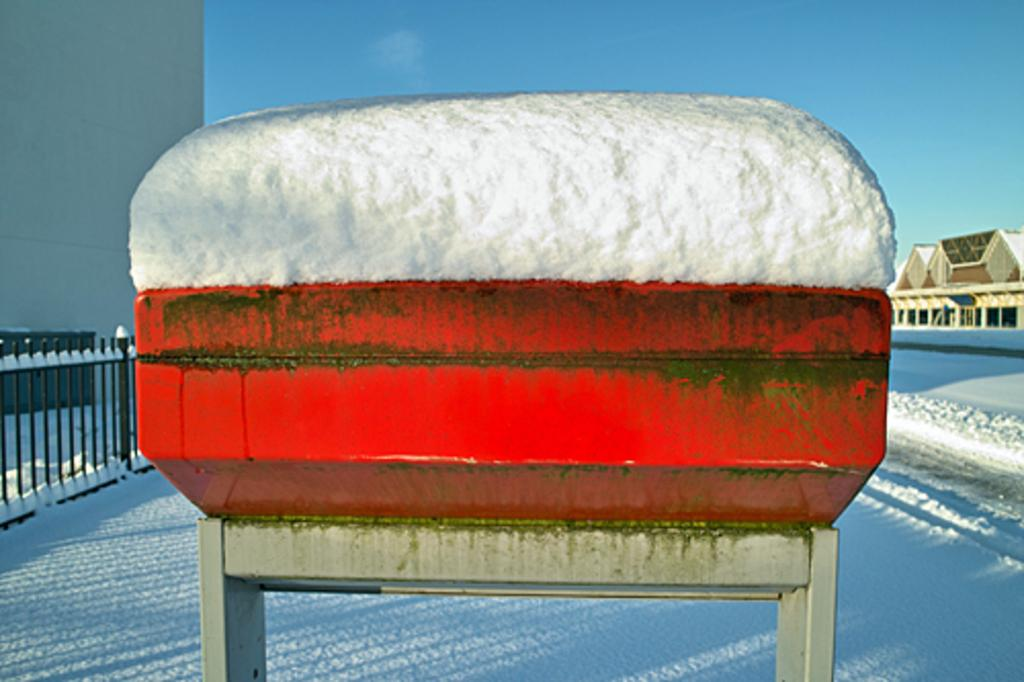What is located on the left side of the image? There is a railing on the left side of the image. What is in the middle of the image? There is a table in the middle of the image. What is on top of the table? There is snow on the table. What can be seen on the right side of the image? There are houses on the right side of the image. What is visible at the top of the image? The sky is visible at the top of the image. What riddle is being solved on the table in the image? There is no riddle present in the image; it features a table with snow on it. What type of education is being provided in the hall in the image? There is no hall or education present in the image; it features a table with snow on it, a railing on the left side, houses on the right side, and a visible sky. 